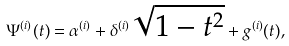<formula> <loc_0><loc_0><loc_500><loc_500>\Psi ^ { ( i ) } ( t ) = \alpha ^ { ( i ) } + \delta ^ { ( i ) } \sqrt { 1 - t ^ { 2 } } + g ^ { ( i ) } ( t ) ,</formula> 